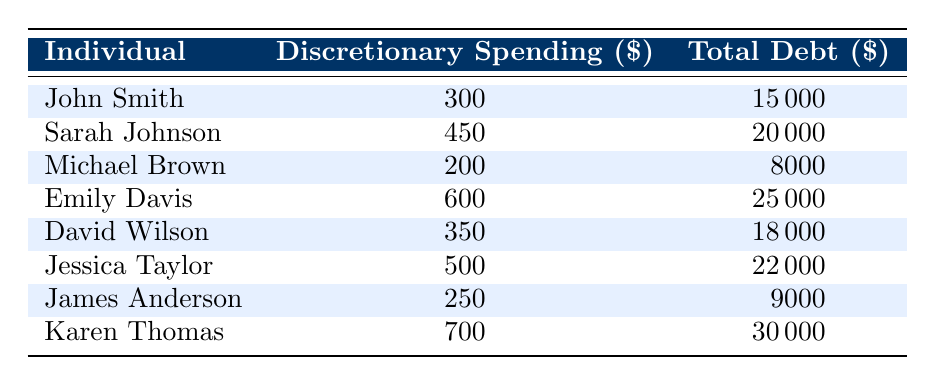What is the total discretionary spending across all individuals? To find the total discretionary spending, sum up the discretionary spending values from the table: 300 + 450 + 200 + 600 + 350 + 500 + 250 + 700 = 3450.
Answer: 3450 Which individual has the highest total debt? By examining the total debt values, Karen Thomas has the highest total debt of 30000, which is greater than all other individuals.
Answer: Karen Thomas Is it true that Sarah Johnson's discretionary spending is higher than Emily Davis's? Comparing Sarah Johnson's discretionary spending of 450 with Emily Davis's spending of 600, we find that 450 is not higher than 600, thus the statement is false.
Answer: No What is the average total debt of these individuals? To find the average total debt, first sum the total debt values: 15000 + 20000 + 8000 + 25000 + 18000 + 22000 + 9000 + 30000 = 126000. There are 8 individuals, so the average is 126000 / 8 = 15750.
Answer: 15750 If we consider those with discretionary spending over 400, what is the average total debt of this group? The individuals with discretionary spending over 400 are Sarah Johnson (20000), Emily Davis (25000), David Wilson (18000), Jessica Taylor (22000), and Karen Thomas (30000). Their total debt is 20000 + 25000 + 18000 + 22000 + 30000 = 115000. There are 5 individuals in this group, so the average is 115000 / 5 = 23000.
Answer: 23000 Which individual has the lowest discretionary spending? Based on the discretionary spending values listed, Michael Brown has the lowest discretionary spending at 200, which is lower than the spending of all other individuals.
Answer: Michael Brown Is there any individual with discretionary spending exceeding $600 and total debt less than $20000? We examine the discretionary spending over 600: Karen Thomas has 700 and total debt of 30000, which is more than 20000. Therefore, no individuals meet the criteria of having discretionary spending exceeding 600 with total debt less than 20000.
Answer: No Calculate the difference in total debt between the individual with the highest discretionary spending and the individual with the lowest. The individual with the highest discretionary spending is Karen Thomas with 700 and total debt of 30000. The individual with the lowest discretionary spending is Michael Brown with 200 and total debt of 8000. The difference in total debt is 30000 - 8000 = 22000.
Answer: 22000 